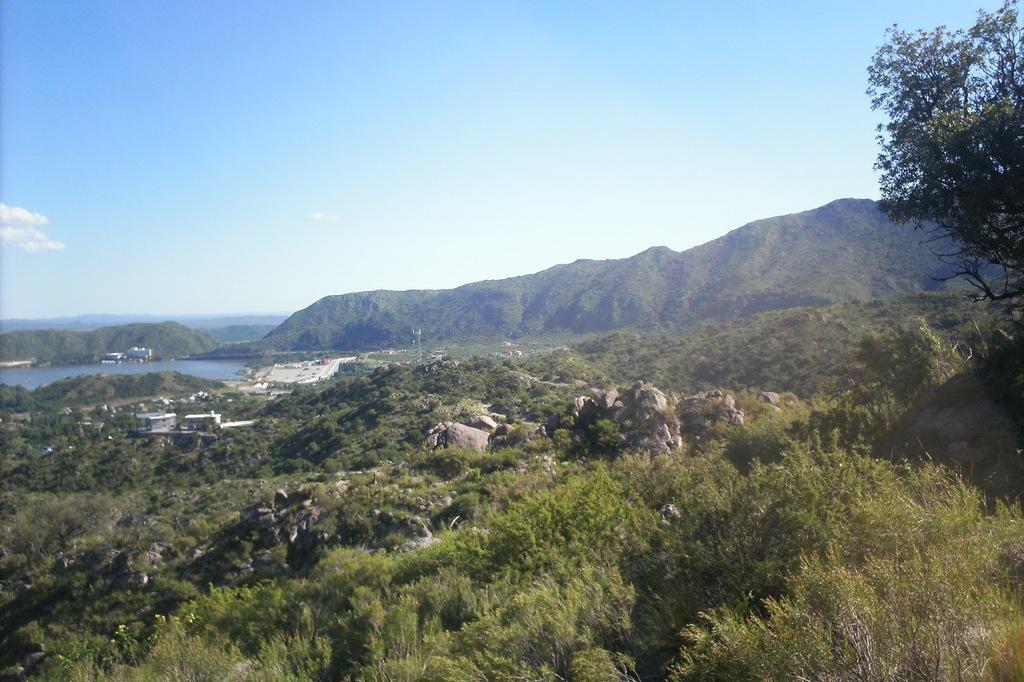Describe this image in one or two sentences. In this image there are trees, stones, there are houses and there is water. In the background there are mountains and the sky is cloudy. 